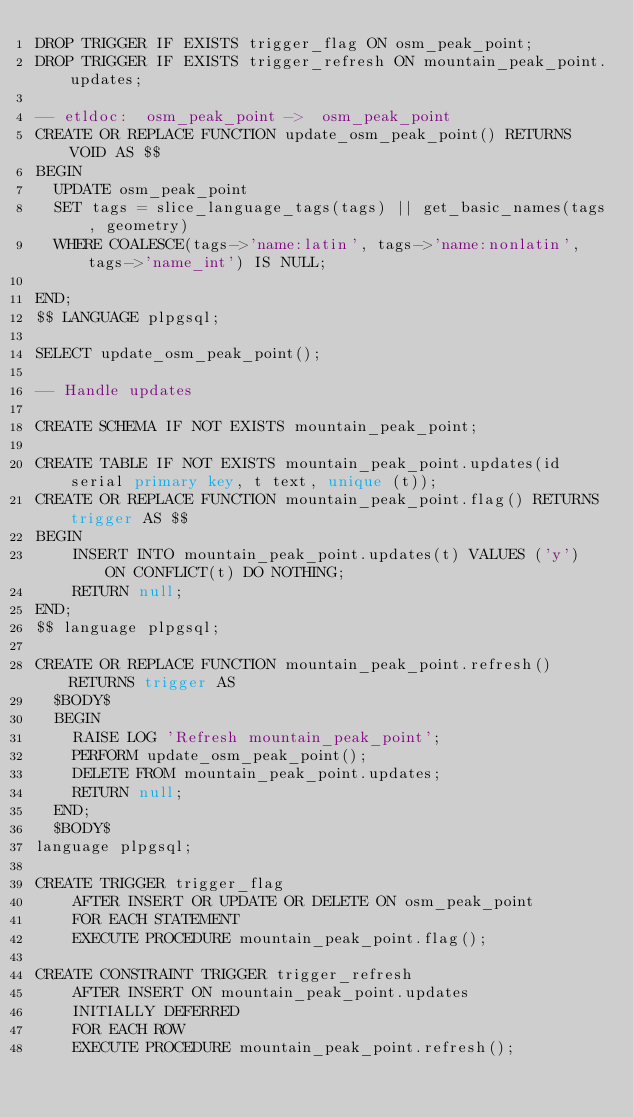<code> <loc_0><loc_0><loc_500><loc_500><_SQL_>DROP TRIGGER IF EXISTS trigger_flag ON osm_peak_point;
DROP TRIGGER IF EXISTS trigger_refresh ON mountain_peak_point.updates;

-- etldoc:  osm_peak_point ->  osm_peak_point
CREATE OR REPLACE FUNCTION update_osm_peak_point() RETURNS VOID AS $$
BEGIN
  UPDATE osm_peak_point
  SET tags = slice_language_tags(tags) || get_basic_names(tags, geometry)
  WHERE COALESCE(tags->'name:latin', tags->'name:nonlatin', tags->'name_int') IS NULL;

END;
$$ LANGUAGE plpgsql;

SELECT update_osm_peak_point();

-- Handle updates

CREATE SCHEMA IF NOT EXISTS mountain_peak_point;

CREATE TABLE IF NOT EXISTS mountain_peak_point.updates(id serial primary key, t text, unique (t));
CREATE OR REPLACE FUNCTION mountain_peak_point.flag() RETURNS trigger AS $$
BEGIN
    INSERT INTO mountain_peak_point.updates(t) VALUES ('y')  ON CONFLICT(t) DO NOTHING;
    RETURN null;
END;
$$ language plpgsql;

CREATE OR REPLACE FUNCTION mountain_peak_point.refresh() RETURNS trigger AS
  $BODY$
  BEGIN
    RAISE LOG 'Refresh mountain_peak_point';
    PERFORM update_osm_peak_point();
    DELETE FROM mountain_peak_point.updates;
    RETURN null;
  END;
  $BODY$
language plpgsql;

CREATE TRIGGER trigger_flag
    AFTER INSERT OR UPDATE OR DELETE ON osm_peak_point
    FOR EACH STATEMENT
    EXECUTE PROCEDURE mountain_peak_point.flag();

CREATE CONSTRAINT TRIGGER trigger_refresh
    AFTER INSERT ON mountain_peak_point.updates
    INITIALLY DEFERRED
    FOR EACH ROW
    EXECUTE PROCEDURE mountain_peak_point.refresh();
</code> 